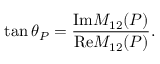Convert formula to latex. <formula><loc_0><loc_0><loc_500><loc_500>\tan { \theta } _ { P } = \frac { { I m } M _ { 1 2 } ( P ) } { { R e } M _ { 1 2 } ( P ) } .</formula> 